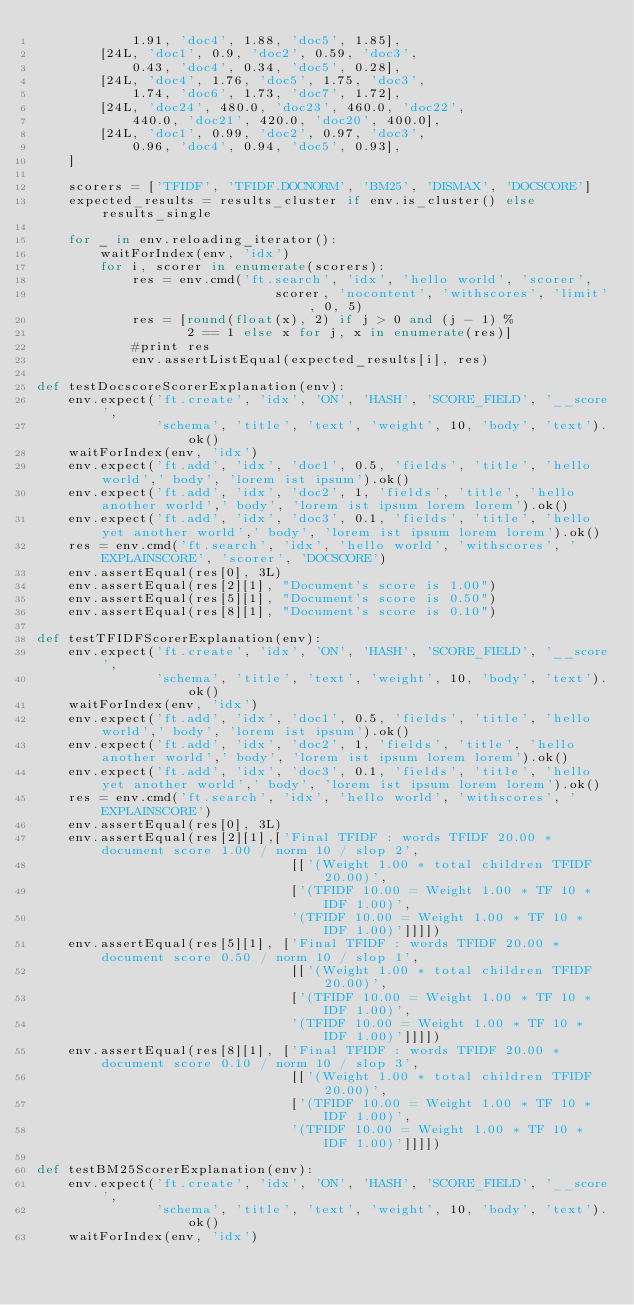Convert code to text. <code><loc_0><loc_0><loc_500><loc_500><_Python_>            1.91, 'doc4', 1.88, 'doc5', 1.85],
        [24L, 'doc1', 0.9, 'doc2', 0.59, 'doc3',
            0.43, 'doc4', 0.34, 'doc5', 0.28],
        [24L, 'doc4', 1.76, 'doc5', 1.75, 'doc3',
            1.74, 'doc6', 1.73, 'doc7', 1.72],
        [24L, 'doc24', 480.0, 'doc23', 460.0, 'doc22',
            440.0, 'doc21', 420.0, 'doc20', 400.0],
        [24L, 'doc1', 0.99, 'doc2', 0.97, 'doc3',
            0.96, 'doc4', 0.94, 'doc5', 0.93],
    ]

    scorers = ['TFIDF', 'TFIDF.DOCNORM', 'BM25', 'DISMAX', 'DOCSCORE']
    expected_results = results_cluster if env.is_cluster() else results_single

    for _ in env.reloading_iterator():
        waitForIndex(env, 'idx')
        for i, scorer in enumerate(scorers):
            res = env.cmd('ft.search', 'idx', 'hello world', 'scorer',
                              scorer, 'nocontent', 'withscores', 'limit', 0, 5)
            res = [round(float(x), 2) if j > 0 and (j - 1) %
                   2 == 1 else x for j, x in enumerate(res)]
            #print res
            env.assertListEqual(expected_results[i], res)

def testDocscoreScorerExplanation(env):
    env.expect('ft.create', 'idx', 'ON', 'HASH', 'SCORE_FIELD', '__score',
               'schema', 'title', 'text', 'weight', 10, 'body', 'text').ok()
    waitForIndex(env, 'idx')
    env.expect('ft.add', 'idx', 'doc1', 0.5, 'fields', 'title', 'hello world',' body', 'lorem ist ipsum').ok()
    env.expect('ft.add', 'idx', 'doc2', 1, 'fields', 'title', 'hello another world',' body', 'lorem ist ipsum lorem lorem').ok()
    env.expect('ft.add', 'idx', 'doc3', 0.1, 'fields', 'title', 'hello yet another world',' body', 'lorem ist ipsum lorem lorem').ok()
    res = env.cmd('ft.search', 'idx', 'hello world', 'withscores', 'EXPLAINSCORE', 'scorer', 'DOCSCORE')
    env.assertEqual(res[0], 3L)
    env.assertEqual(res[2][1], "Document's score is 1.00")
    env.assertEqual(res[5][1], "Document's score is 0.50")
    env.assertEqual(res[8][1], "Document's score is 0.10")

def testTFIDFScorerExplanation(env):
    env.expect('ft.create', 'idx', 'ON', 'HASH', 'SCORE_FIELD', '__score',
               'schema', 'title', 'text', 'weight', 10, 'body', 'text').ok()
    waitForIndex(env, 'idx')
    env.expect('ft.add', 'idx', 'doc1', 0.5, 'fields', 'title', 'hello world',' body', 'lorem ist ipsum').ok()
    env.expect('ft.add', 'idx', 'doc2', 1, 'fields', 'title', 'hello another world',' body', 'lorem ist ipsum lorem lorem').ok()
    env.expect('ft.add', 'idx', 'doc3', 0.1, 'fields', 'title', 'hello yet another world',' body', 'lorem ist ipsum lorem lorem').ok()
    res = env.cmd('ft.search', 'idx', 'hello world', 'withscores', 'EXPLAINSCORE')
    env.assertEqual(res[0], 3L)
    env.assertEqual(res[2][1],['Final TFIDF : words TFIDF 20.00 * document score 1.00 / norm 10 / slop 2',
                                [['(Weight 1.00 * total children TFIDF 20.00)',
                                ['(TFIDF 10.00 = Weight 1.00 * TF 10 * IDF 1.00)',
                                '(TFIDF 10.00 = Weight 1.00 * TF 10 * IDF 1.00)']]]])
    env.assertEqual(res[5][1], ['Final TFIDF : words TFIDF 20.00 * document score 0.50 / norm 10 / slop 1',
                                [['(Weight 1.00 * total children TFIDF 20.00)',
                                ['(TFIDF 10.00 = Weight 1.00 * TF 10 * IDF 1.00)',
                                '(TFIDF 10.00 = Weight 1.00 * TF 10 * IDF 1.00)']]]])
    env.assertEqual(res[8][1], ['Final TFIDF : words TFIDF 20.00 * document score 0.10 / norm 10 / slop 3',
                                [['(Weight 1.00 * total children TFIDF 20.00)',
                                ['(TFIDF 10.00 = Weight 1.00 * TF 10 * IDF 1.00)',
                                '(TFIDF 10.00 = Weight 1.00 * TF 10 * IDF 1.00)']]]])

def testBM25ScorerExplanation(env):
    env.expect('ft.create', 'idx', 'ON', 'HASH', 'SCORE_FIELD', '__score',
               'schema', 'title', 'text', 'weight', 10, 'body', 'text').ok()
    waitForIndex(env, 'idx')</code> 